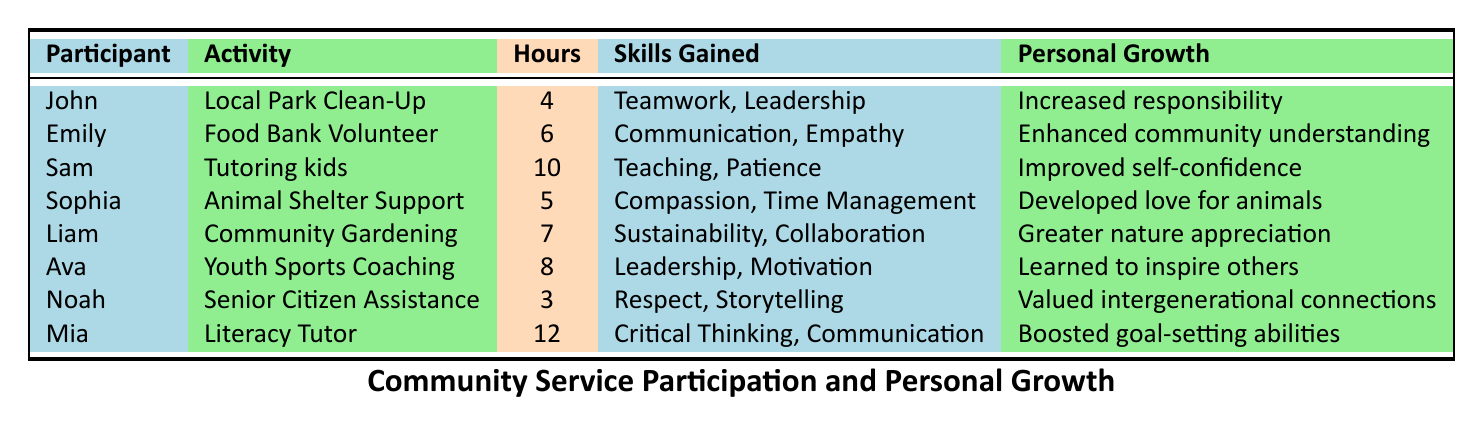What is the Community Service Activity that Sam participated in? Sam participated in "Tutoring underprivileged kids" as his community service activity.
Answer: Tutoring underprivileged kids How many hours did Mia spend on her community service activity? Mia spent 12 hours on her community service activity.
Answer: 12 Which participant gained skills related to "Communication" and "Empathy"? Emily gained skills related to "Communication" and "Empathy" during her community service activity.
Answer: Emily How many total hours did John and Liam spend on their community service activities combined? John spent 4 hours and Liam spent 7 hours. Adding these gives 4 + 7 = 11 hours in total.
Answer: 11 Did any participant develop a greater appreciation for nature through their community service? Yes, Liam developed a greater appreciation for nature as a result of his community service activity.
Answer: Yes Who spent the least amount of time in community service, and what was their activity? Noah spent the least amount of time at 3 hours, participating in "Senior Citizen Assistance".
Answer: Noah; Senior Citizen Assistance Among the participants, how many people gained leadership-related skills? John and Ava both gained leadership-related skills. Counting them gives a total of 2 participants.
Answer: 2 What personal growth did Liam experience through his activity? Liam experienced "Greater appreciation for nature" as a result of his community service activity.
Answer: Greater appreciation for nature What is the average number of hours spent on community service activities across all participants? The total hours spent by all participants are: 4 + 6 + 10 + 5 + 7 + 8 + 3 + 12 = 55 hours. There are 8 participants, so the average is 55/8 = 6.875 hours.
Answer: 6.875 